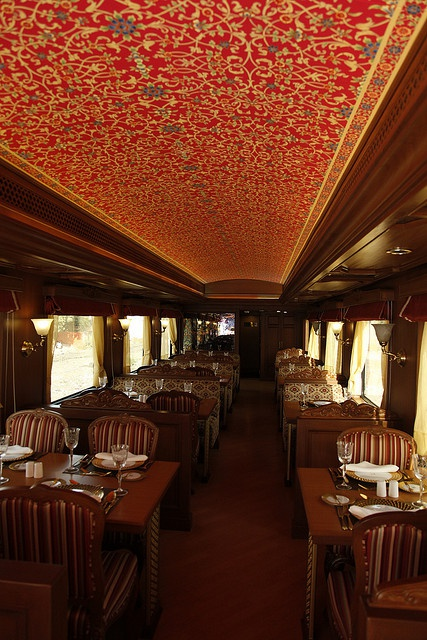Describe the objects in this image and their specific colors. I can see chair in brown, black, maroon, and gray tones, dining table in brown, maroon, black, and gray tones, dining table in brown, maroon, black, and tan tones, chair in brown, black, and maroon tones, and chair in brown, maroon, and tan tones in this image. 